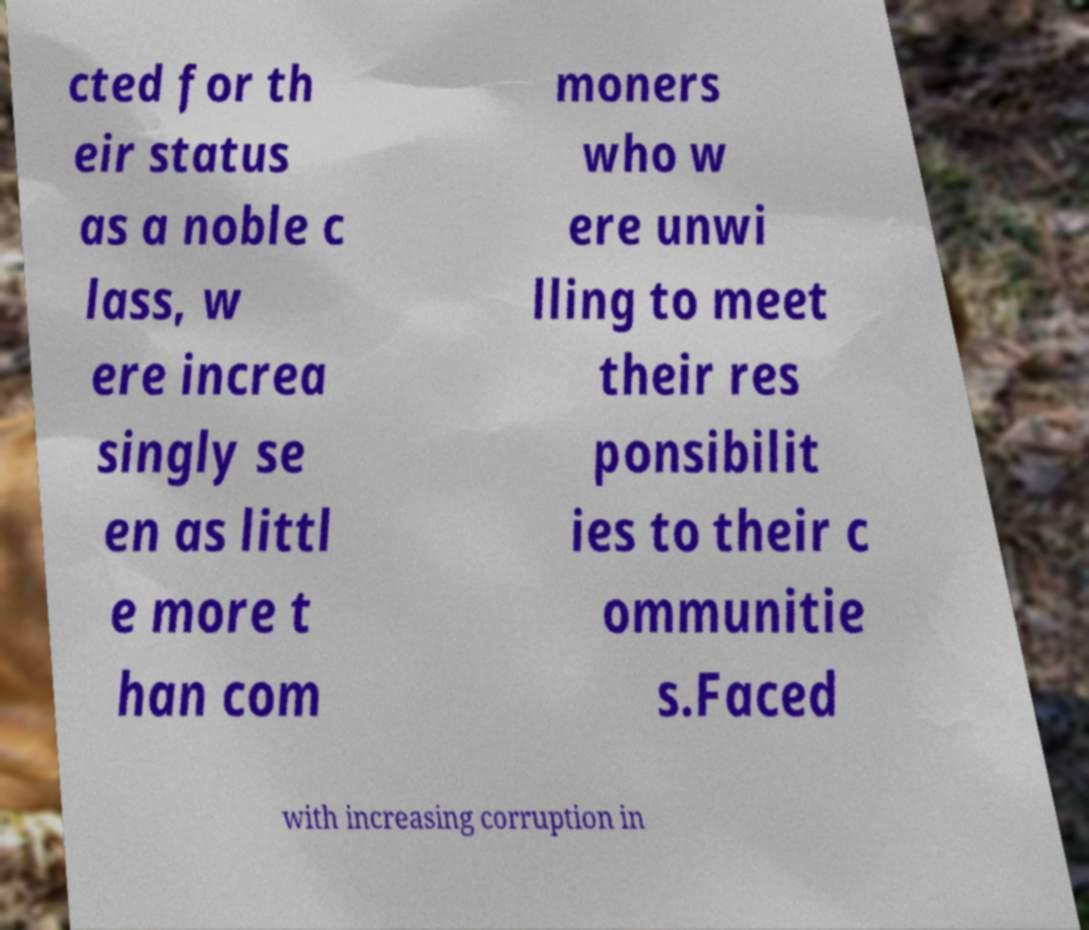Please identify and transcribe the text found in this image. cted for th eir status as a noble c lass, w ere increa singly se en as littl e more t han com moners who w ere unwi lling to meet their res ponsibilit ies to their c ommunitie s.Faced with increasing corruption in 